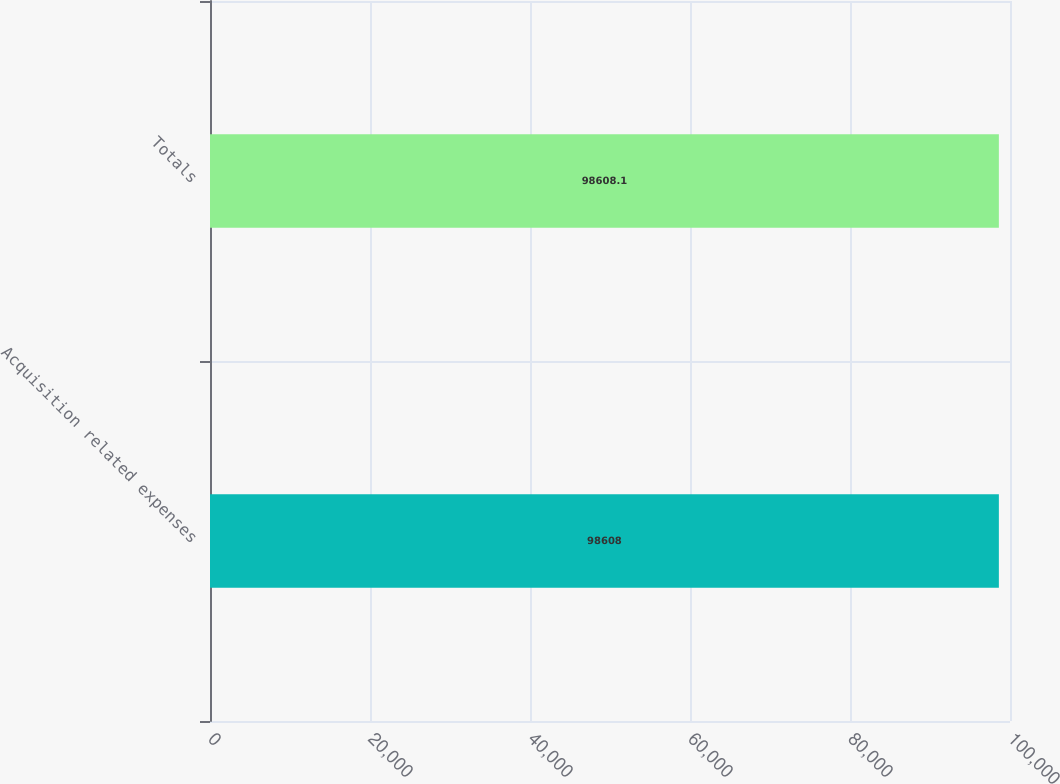Convert chart. <chart><loc_0><loc_0><loc_500><loc_500><bar_chart><fcel>Acquisition related expenses<fcel>Totals<nl><fcel>98608<fcel>98608.1<nl></chart> 